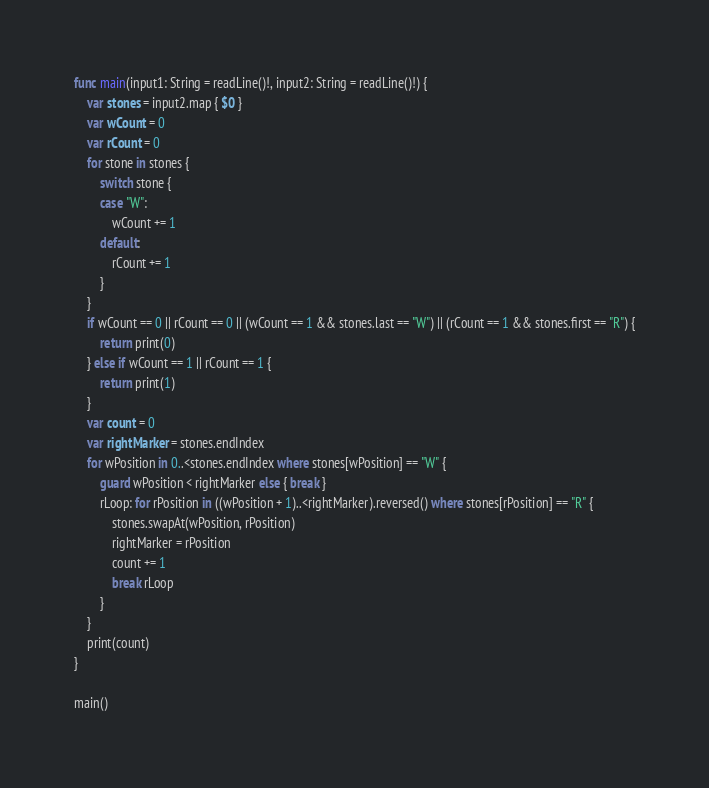<code> <loc_0><loc_0><loc_500><loc_500><_Swift_>func main(input1: String = readLine()!, input2: String = readLine()!) {
    var stones = input2.map { $0 }
    var wCount = 0
    var rCount = 0
    for stone in stones {
        switch stone {
        case "W":
            wCount += 1
        default:
            rCount += 1
        }
    }
    if wCount == 0 || rCount == 0 || (wCount == 1 && stones.last == "W") || (rCount == 1 && stones.first == "R") {
        return print(0)
    } else if wCount == 1 || rCount == 1 {
        return print(1)
    }
    var count = 0
    var rightMarker = stones.endIndex
    for wPosition in 0..<stones.endIndex where stones[wPosition] == "W" {
        guard wPosition < rightMarker else { break }
        rLoop: for rPosition in ((wPosition + 1)..<rightMarker).reversed() where stones[rPosition] == "R" {
            stones.swapAt(wPosition, rPosition)
            rightMarker = rPosition
            count += 1
            break rLoop
        }
    }
    print(count)
}

main()</code> 